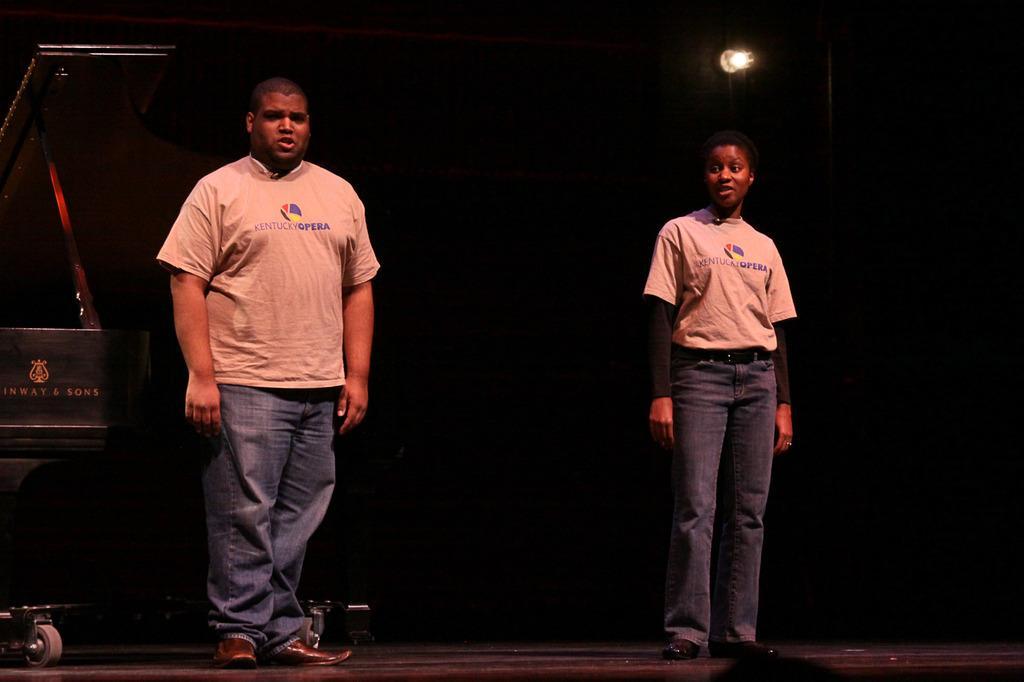Describe this image in one or two sentences. There is a man and woman standing on stage. 